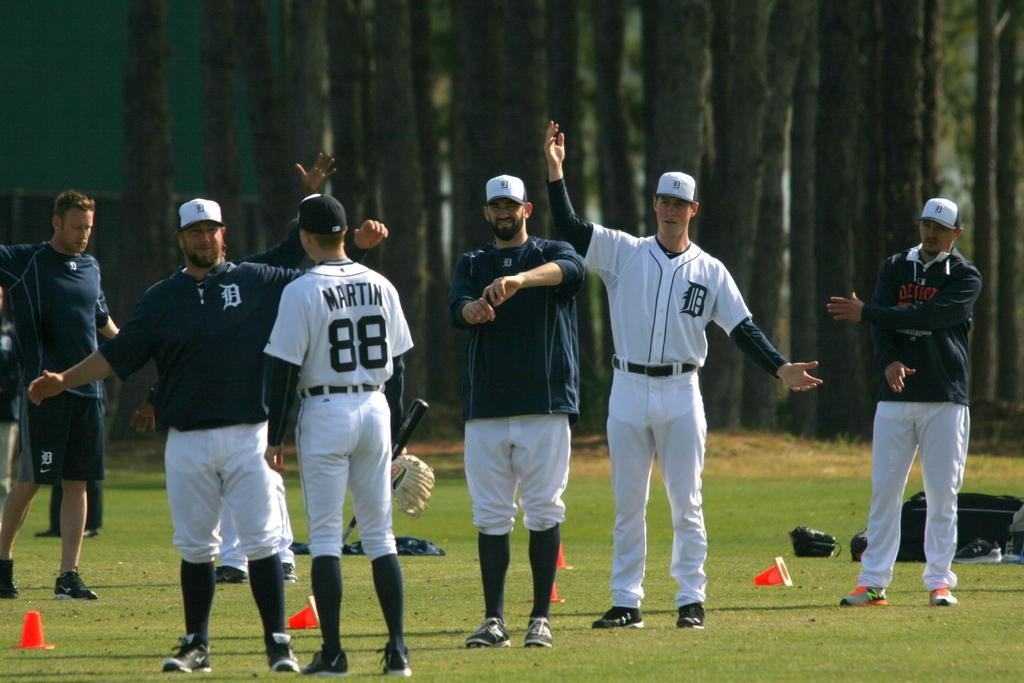Provide a one-sentence caption for the provided image. Baseball player Martin, number 88, is talking to people on a field. 